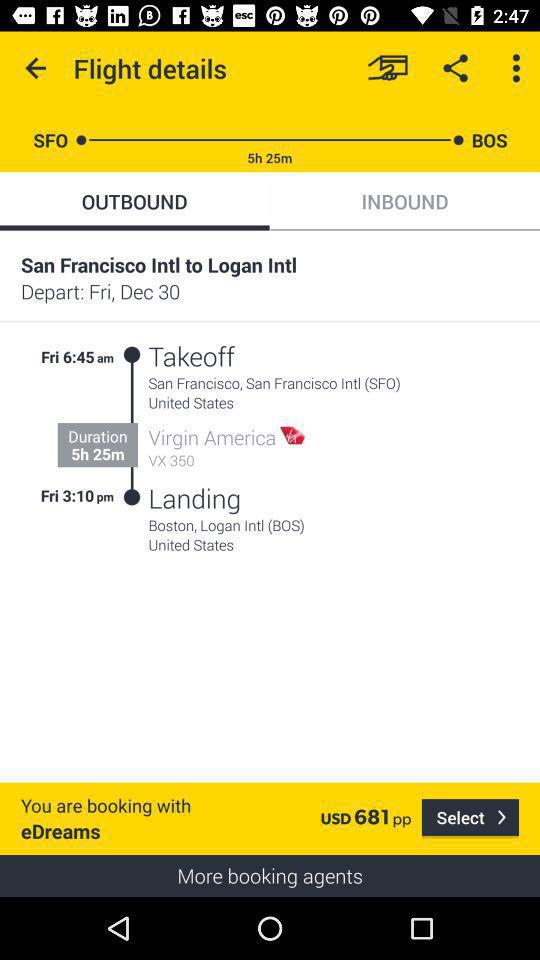What is the name of the destination airport? The name of the destination airport is "Boston, Logan Intl (BOS)". 